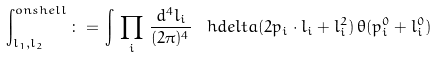<formula> <loc_0><loc_0><loc_500><loc_500>\int _ { l _ { 1 } , l _ { 2 } } ^ { o n s h e l l } \, \colon = \, \int \, \prod _ { i } \, \frac { d ^ { 4 } l _ { i } } { ( 2 \pi ) ^ { 4 } } \, \ h d e l t a ( 2 p _ { i } \cdot l _ { i } + l _ { i } ^ { 2 } ) \, \theta ( p _ { i } ^ { 0 } + l _ { i } ^ { 0 } )</formula> 